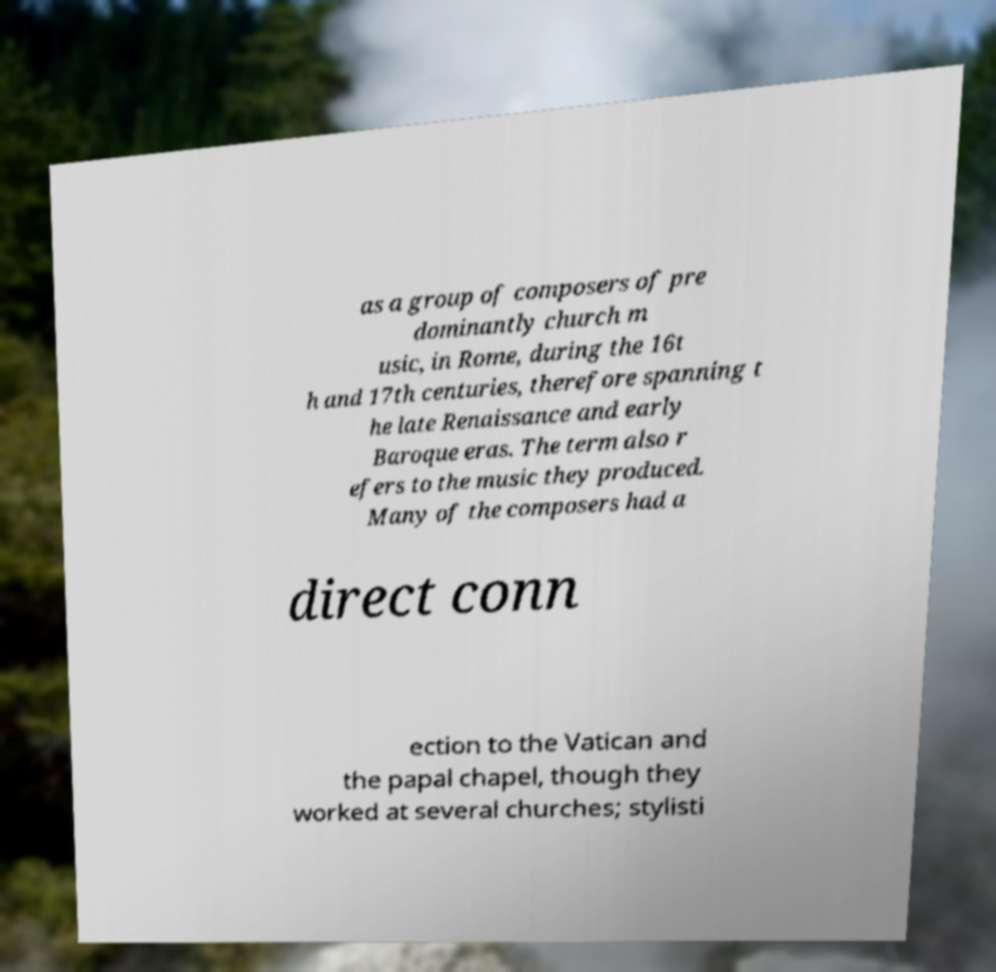Can you accurately transcribe the text from the provided image for me? as a group of composers of pre dominantly church m usic, in Rome, during the 16t h and 17th centuries, therefore spanning t he late Renaissance and early Baroque eras. The term also r efers to the music they produced. Many of the composers had a direct conn ection to the Vatican and the papal chapel, though they worked at several churches; stylisti 